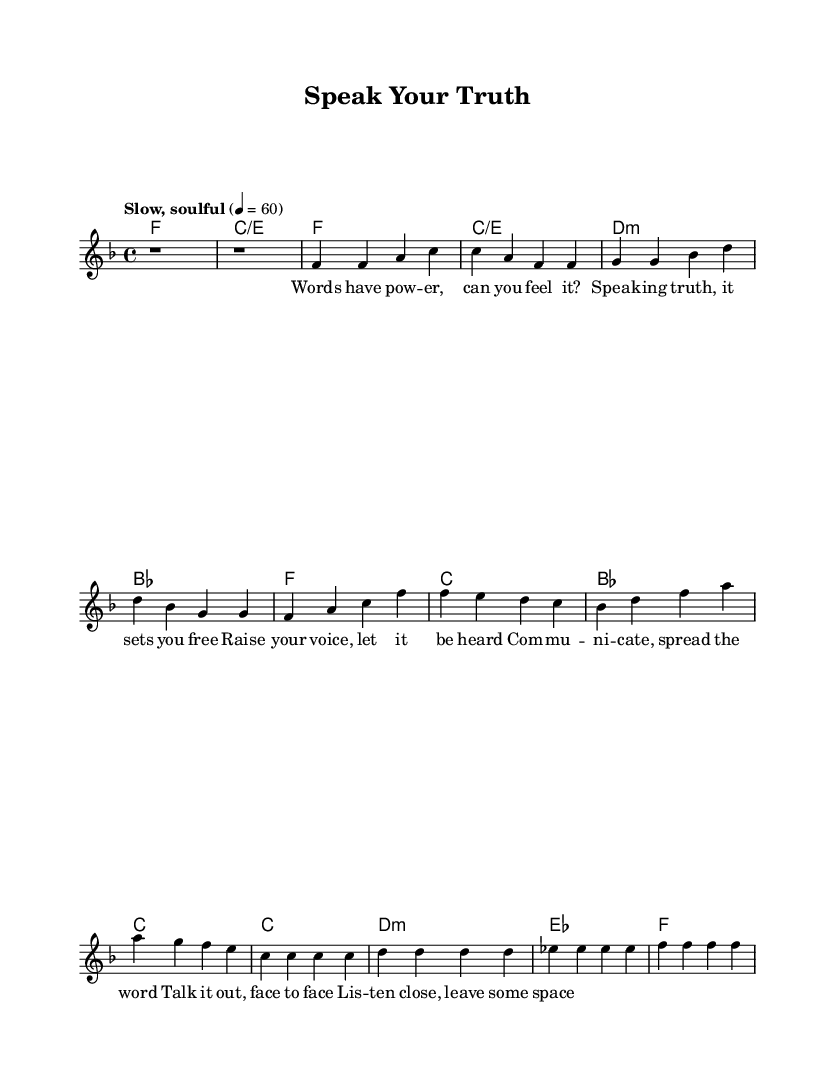What is the key signature of this music? The key signature is F major, which has one flat (B flat).
Answer: F major What is the time signature of this music? The time signature is 4/4, indicating four beats per measure.
Answer: 4/4 What is the tempo marking of this music? The tempo marking is "Slow, soulful" with a metronome marking of 60 beats per minute.
Answer: Slow, soulful How many measures are in the chorus section? The chorus consists of four measures, as indicated.
Answer: 4 What is the predominant theme conveyed in the lyrics? The lyrics emphasize the importance of communication and expressing oneself.
Answer: Communication What musical form does this piece follow? The piece follows a structure of Verse, Chorus, and Bridge, typical of soul ballads.
Answer: Verse, Chorus, Bridge How does the bridge contribute to the overall message of the song? The bridge provides a reflective approach on communication, focusing on listening and face-to-face interaction, which enhances the song's message.
Answer: Reflection on communication 